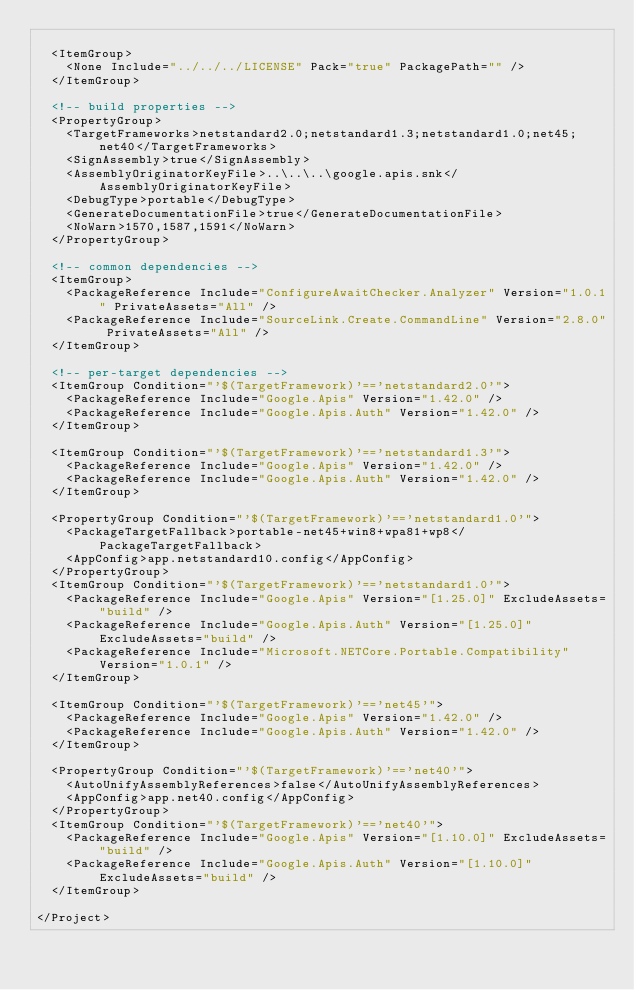Convert code to text. <code><loc_0><loc_0><loc_500><loc_500><_XML_>
  <ItemGroup>
    <None Include="../../../LICENSE" Pack="true" PackagePath="" />
  </ItemGroup>

  <!-- build properties -->
  <PropertyGroup>
    <TargetFrameworks>netstandard2.0;netstandard1.3;netstandard1.0;net45;net40</TargetFrameworks>
    <SignAssembly>true</SignAssembly>
    <AssemblyOriginatorKeyFile>..\..\..\google.apis.snk</AssemblyOriginatorKeyFile>
    <DebugType>portable</DebugType>
    <GenerateDocumentationFile>true</GenerateDocumentationFile>
    <NoWarn>1570,1587,1591</NoWarn>
  </PropertyGroup>

  <!-- common dependencies -->
  <ItemGroup>
    <PackageReference Include="ConfigureAwaitChecker.Analyzer" Version="1.0.1" PrivateAssets="All" />
    <PackageReference Include="SourceLink.Create.CommandLine" Version="2.8.0" PrivateAssets="All" />
  </ItemGroup>
  
  <!-- per-target dependencies -->
  <ItemGroup Condition="'$(TargetFramework)'=='netstandard2.0'">
    <PackageReference Include="Google.Apis" Version="1.42.0" />
    <PackageReference Include="Google.Apis.Auth" Version="1.42.0" />
  </ItemGroup>

  <ItemGroup Condition="'$(TargetFramework)'=='netstandard1.3'">
    <PackageReference Include="Google.Apis" Version="1.42.0" />
    <PackageReference Include="Google.Apis.Auth" Version="1.42.0" />
  </ItemGroup>

  <PropertyGroup Condition="'$(TargetFramework)'=='netstandard1.0'">
    <PackageTargetFallback>portable-net45+win8+wpa81+wp8</PackageTargetFallback>
    <AppConfig>app.netstandard10.config</AppConfig>
  </PropertyGroup>
  <ItemGroup Condition="'$(TargetFramework)'=='netstandard1.0'">
    <PackageReference Include="Google.Apis" Version="[1.25.0]" ExcludeAssets="build" />
    <PackageReference Include="Google.Apis.Auth" Version="[1.25.0]" ExcludeAssets="build" />
    <PackageReference Include="Microsoft.NETCore.Portable.Compatibility" Version="1.0.1" />
  </ItemGroup>

  <ItemGroup Condition="'$(TargetFramework)'=='net45'">
    <PackageReference Include="Google.Apis" Version="1.42.0" />
    <PackageReference Include="Google.Apis.Auth" Version="1.42.0" />
  </ItemGroup>

  <PropertyGroup Condition="'$(TargetFramework)'=='net40'">
    <AutoUnifyAssemblyReferences>false</AutoUnifyAssemblyReferences>
    <AppConfig>app.net40.config</AppConfig>
  </PropertyGroup>
  <ItemGroup Condition="'$(TargetFramework)'=='net40'">
    <PackageReference Include="Google.Apis" Version="[1.10.0]" ExcludeAssets="build" />
    <PackageReference Include="Google.Apis.Auth" Version="[1.10.0]" ExcludeAssets="build" />
  </ItemGroup>

</Project>
</code> 